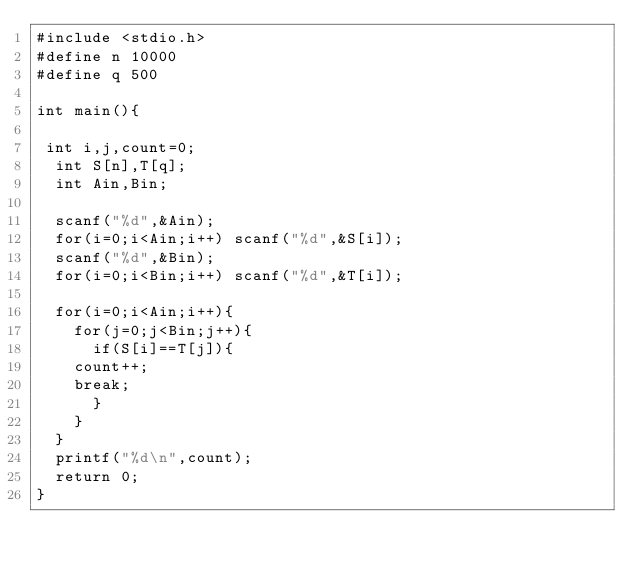<code> <loc_0><loc_0><loc_500><loc_500><_C_>#include <stdio.h>
#define n 10000
#define q 500

int main(){
 
 int i,j,count=0;
  int S[n],T[q];
  int Ain,Bin;
  
  scanf("%d",&Ain);  
  for(i=0;i<Ain;i++) scanf("%d",&S[i]);
  scanf("%d",&Bin);
  for(i=0;i<Bin;i++) scanf("%d",&T[i]);
  
  for(i=0;i<Ain;i++){
    for(j=0;j<Bin;j++){
      if(S[i]==T[j]){
	count++;
	break;
      }
    }
  }
  printf("%d\n",count);
  return 0;
}</code> 